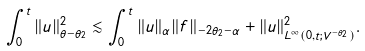<formula> <loc_0><loc_0><loc_500><loc_500>\int _ { 0 } ^ { t } \| u \| _ { \theta - \theta _ { 2 } } ^ { 2 } \lesssim \int _ { 0 } ^ { t } \| u \| _ { \alpha } \| f \| _ { - 2 \theta _ { 2 } - \alpha } + \| u \| _ { L ^ { \infty } ( 0 , t ; V ^ { - \theta _ { 2 } } ) } ^ { 2 } .</formula> 